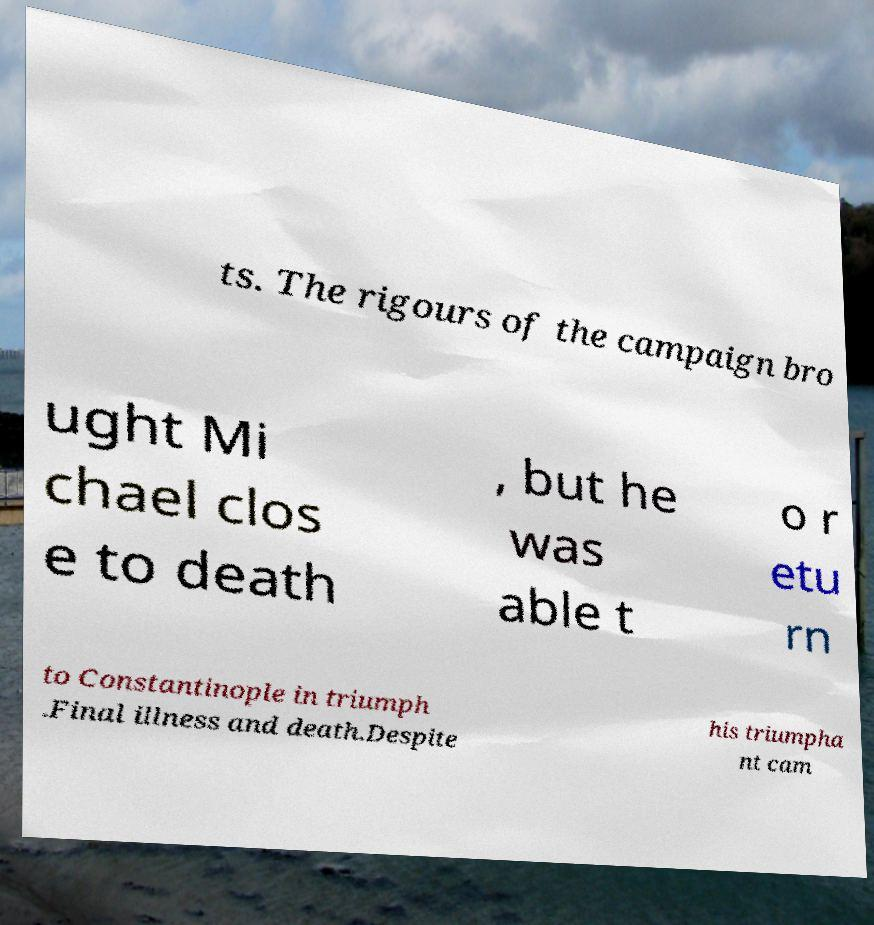Please identify and transcribe the text found in this image. ts. The rigours of the campaign bro ught Mi chael clos e to death , but he was able t o r etu rn to Constantinople in triumph .Final illness and death.Despite his triumpha nt cam 